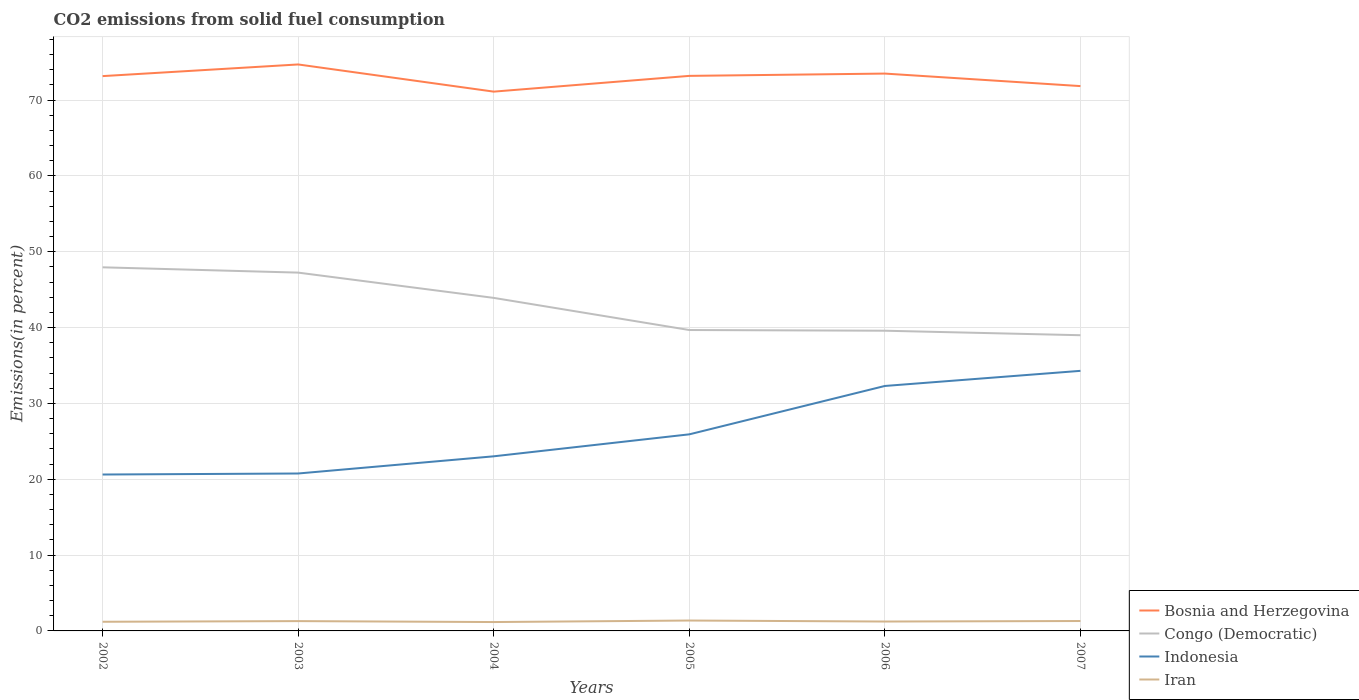Across all years, what is the maximum total CO2 emitted in Indonesia?
Offer a very short reply. 20.62. What is the total total CO2 emitted in Indonesia in the graph?
Offer a terse response. -2.9. What is the difference between the highest and the second highest total CO2 emitted in Bosnia and Herzegovina?
Offer a very short reply. 3.58. How many years are there in the graph?
Your answer should be very brief. 6. What is the difference between two consecutive major ticks on the Y-axis?
Ensure brevity in your answer.  10. Are the values on the major ticks of Y-axis written in scientific E-notation?
Provide a short and direct response. No. Does the graph contain any zero values?
Offer a very short reply. No. What is the title of the graph?
Give a very brief answer. CO2 emissions from solid fuel consumption. What is the label or title of the Y-axis?
Provide a succinct answer. Emissions(in percent). What is the Emissions(in percent) in Bosnia and Herzegovina in 2002?
Keep it short and to the point. 73.15. What is the Emissions(in percent) in Congo (Democratic) in 2002?
Keep it short and to the point. 47.94. What is the Emissions(in percent) in Indonesia in 2002?
Your response must be concise. 20.62. What is the Emissions(in percent) in Iran in 2002?
Make the answer very short. 1.21. What is the Emissions(in percent) in Bosnia and Herzegovina in 2003?
Offer a very short reply. 74.69. What is the Emissions(in percent) of Congo (Democratic) in 2003?
Ensure brevity in your answer.  47.24. What is the Emissions(in percent) of Indonesia in 2003?
Provide a short and direct response. 20.76. What is the Emissions(in percent) of Iran in 2003?
Provide a succinct answer. 1.29. What is the Emissions(in percent) in Bosnia and Herzegovina in 2004?
Ensure brevity in your answer.  71.11. What is the Emissions(in percent) of Congo (Democratic) in 2004?
Give a very brief answer. 43.91. What is the Emissions(in percent) of Indonesia in 2004?
Your answer should be very brief. 23.02. What is the Emissions(in percent) in Iran in 2004?
Your answer should be compact. 1.17. What is the Emissions(in percent) in Bosnia and Herzegovina in 2005?
Your answer should be very brief. 73.18. What is the Emissions(in percent) of Congo (Democratic) in 2005?
Your answer should be compact. 39.68. What is the Emissions(in percent) in Indonesia in 2005?
Your answer should be compact. 25.92. What is the Emissions(in percent) of Iran in 2005?
Your answer should be very brief. 1.37. What is the Emissions(in percent) of Bosnia and Herzegovina in 2006?
Ensure brevity in your answer.  73.49. What is the Emissions(in percent) of Congo (Democratic) in 2006?
Offer a terse response. 39.58. What is the Emissions(in percent) in Indonesia in 2006?
Your answer should be compact. 32.3. What is the Emissions(in percent) in Iran in 2006?
Your response must be concise. 1.24. What is the Emissions(in percent) in Bosnia and Herzegovina in 2007?
Provide a short and direct response. 71.84. What is the Emissions(in percent) in Congo (Democratic) in 2007?
Provide a short and direct response. 38.99. What is the Emissions(in percent) of Indonesia in 2007?
Make the answer very short. 34.29. What is the Emissions(in percent) of Iran in 2007?
Ensure brevity in your answer.  1.31. Across all years, what is the maximum Emissions(in percent) of Bosnia and Herzegovina?
Offer a terse response. 74.69. Across all years, what is the maximum Emissions(in percent) of Congo (Democratic)?
Your answer should be very brief. 47.94. Across all years, what is the maximum Emissions(in percent) of Indonesia?
Offer a terse response. 34.29. Across all years, what is the maximum Emissions(in percent) in Iran?
Give a very brief answer. 1.37. Across all years, what is the minimum Emissions(in percent) of Bosnia and Herzegovina?
Your answer should be very brief. 71.11. Across all years, what is the minimum Emissions(in percent) of Congo (Democratic)?
Make the answer very short. 38.99. Across all years, what is the minimum Emissions(in percent) of Indonesia?
Give a very brief answer. 20.62. Across all years, what is the minimum Emissions(in percent) of Iran?
Provide a succinct answer. 1.17. What is the total Emissions(in percent) in Bosnia and Herzegovina in the graph?
Your answer should be very brief. 437.46. What is the total Emissions(in percent) of Congo (Democratic) in the graph?
Keep it short and to the point. 257.35. What is the total Emissions(in percent) of Indonesia in the graph?
Your answer should be very brief. 156.91. What is the total Emissions(in percent) of Iran in the graph?
Your response must be concise. 7.59. What is the difference between the Emissions(in percent) in Bosnia and Herzegovina in 2002 and that in 2003?
Ensure brevity in your answer.  -1.54. What is the difference between the Emissions(in percent) of Congo (Democratic) in 2002 and that in 2003?
Offer a terse response. 0.7. What is the difference between the Emissions(in percent) in Indonesia in 2002 and that in 2003?
Your answer should be very brief. -0.13. What is the difference between the Emissions(in percent) of Iran in 2002 and that in 2003?
Offer a very short reply. -0.09. What is the difference between the Emissions(in percent) of Bosnia and Herzegovina in 2002 and that in 2004?
Offer a very short reply. 2.05. What is the difference between the Emissions(in percent) in Congo (Democratic) in 2002 and that in 2004?
Offer a very short reply. 4.03. What is the difference between the Emissions(in percent) of Indonesia in 2002 and that in 2004?
Provide a short and direct response. -2.4. What is the difference between the Emissions(in percent) in Iran in 2002 and that in 2004?
Your answer should be compact. 0.04. What is the difference between the Emissions(in percent) in Bosnia and Herzegovina in 2002 and that in 2005?
Keep it short and to the point. -0.03. What is the difference between the Emissions(in percent) of Congo (Democratic) in 2002 and that in 2005?
Your response must be concise. 8.27. What is the difference between the Emissions(in percent) of Indonesia in 2002 and that in 2005?
Make the answer very short. -5.3. What is the difference between the Emissions(in percent) of Iran in 2002 and that in 2005?
Offer a terse response. -0.16. What is the difference between the Emissions(in percent) of Bosnia and Herzegovina in 2002 and that in 2006?
Ensure brevity in your answer.  -0.33. What is the difference between the Emissions(in percent) of Congo (Democratic) in 2002 and that in 2006?
Ensure brevity in your answer.  8.36. What is the difference between the Emissions(in percent) in Indonesia in 2002 and that in 2006?
Your answer should be compact. -11.68. What is the difference between the Emissions(in percent) in Iran in 2002 and that in 2006?
Keep it short and to the point. -0.03. What is the difference between the Emissions(in percent) of Bosnia and Herzegovina in 2002 and that in 2007?
Your answer should be compact. 1.32. What is the difference between the Emissions(in percent) in Congo (Democratic) in 2002 and that in 2007?
Your answer should be very brief. 8.95. What is the difference between the Emissions(in percent) in Indonesia in 2002 and that in 2007?
Keep it short and to the point. -13.67. What is the difference between the Emissions(in percent) of Iran in 2002 and that in 2007?
Offer a very short reply. -0.1. What is the difference between the Emissions(in percent) in Bosnia and Herzegovina in 2003 and that in 2004?
Give a very brief answer. 3.58. What is the difference between the Emissions(in percent) in Congo (Democratic) in 2003 and that in 2004?
Offer a very short reply. 3.33. What is the difference between the Emissions(in percent) of Indonesia in 2003 and that in 2004?
Offer a very short reply. -2.27. What is the difference between the Emissions(in percent) in Iran in 2003 and that in 2004?
Provide a short and direct response. 0.12. What is the difference between the Emissions(in percent) in Bosnia and Herzegovina in 2003 and that in 2005?
Provide a succinct answer. 1.51. What is the difference between the Emissions(in percent) in Congo (Democratic) in 2003 and that in 2005?
Provide a short and direct response. 7.57. What is the difference between the Emissions(in percent) in Indonesia in 2003 and that in 2005?
Keep it short and to the point. -5.16. What is the difference between the Emissions(in percent) in Iran in 2003 and that in 2005?
Keep it short and to the point. -0.08. What is the difference between the Emissions(in percent) of Bosnia and Herzegovina in 2003 and that in 2006?
Ensure brevity in your answer.  1.2. What is the difference between the Emissions(in percent) in Congo (Democratic) in 2003 and that in 2006?
Give a very brief answer. 7.66. What is the difference between the Emissions(in percent) of Indonesia in 2003 and that in 2006?
Offer a terse response. -11.54. What is the difference between the Emissions(in percent) of Iran in 2003 and that in 2006?
Offer a very short reply. 0.05. What is the difference between the Emissions(in percent) of Bosnia and Herzegovina in 2003 and that in 2007?
Your answer should be very brief. 2.85. What is the difference between the Emissions(in percent) in Congo (Democratic) in 2003 and that in 2007?
Ensure brevity in your answer.  8.25. What is the difference between the Emissions(in percent) of Indonesia in 2003 and that in 2007?
Provide a succinct answer. -13.53. What is the difference between the Emissions(in percent) of Iran in 2003 and that in 2007?
Your response must be concise. -0.01. What is the difference between the Emissions(in percent) in Bosnia and Herzegovina in 2004 and that in 2005?
Provide a short and direct response. -2.08. What is the difference between the Emissions(in percent) of Congo (Democratic) in 2004 and that in 2005?
Your answer should be very brief. 4.24. What is the difference between the Emissions(in percent) in Indonesia in 2004 and that in 2005?
Make the answer very short. -2.9. What is the difference between the Emissions(in percent) in Iran in 2004 and that in 2005?
Your answer should be very brief. -0.2. What is the difference between the Emissions(in percent) in Bosnia and Herzegovina in 2004 and that in 2006?
Keep it short and to the point. -2.38. What is the difference between the Emissions(in percent) of Congo (Democratic) in 2004 and that in 2006?
Offer a terse response. 4.33. What is the difference between the Emissions(in percent) of Indonesia in 2004 and that in 2006?
Provide a succinct answer. -9.28. What is the difference between the Emissions(in percent) of Iran in 2004 and that in 2006?
Offer a very short reply. -0.07. What is the difference between the Emissions(in percent) of Bosnia and Herzegovina in 2004 and that in 2007?
Provide a short and direct response. -0.73. What is the difference between the Emissions(in percent) of Congo (Democratic) in 2004 and that in 2007?
Keep it short and to the point. 4.92. What is the difference between the Emissions(in percent) in Indonesia in 2004 and that in 2007?
Your response must be concise. -11.27. What is the difference between the Emissions(in percent) of Iran in 2004 and that in 2007?
Your response must be concise. -0.14. What is the difference between the Emissions(in percent) in Bosnia and Herzegovina in 2005 and that in 2006?
Offer a very short reply. -0.3. What is the difference between the Emissions(in percent) in Congo (Democratic) in 2005 and that in 2006?
Your answer should be very brief. 0.09. What is the difference between the Emissions(in percent) of Indonesia in 2005 and that in 2006?
Your response must be concise. -6.38. What is the difference between the Emissions(in percent) of Iran in 2005 and that in 2006?
Your answer should be compact. 0.13. What is the difference between the Emissions(in percent) in Bosnia and Herzegovina in 2005 and that in 2007?
Offer a terse response. 1.35. What is the difference between the Emissions(in percent) of Congo (Democratic) in 2005 and that in 2007?
Make the answer very short. 0.69. What is the difference between the Emissions(in percent) of Indonesia in 2005 and that in 2007?
Ensure brevity in your answer.  -8.37. What is the difference between the Emissions(in percent) in Iran in 2005 and that in 2007?
Ensure brevity in your answer.  0.06. What is the difference between the Emissions(in percent) in Bosnia and Herzegovina in 2006 and that in 2007?
Ensure brevity in your answer.  1.65. What is the difference between the Emissions(in percent) in Congo (Democratic) in 2006 and that in 2007?
Offer a terse response. 0.59. What is the difference between the Emissions(in percent) of Indonesia in 2006 and that in 2007?
Make the answer very short. -1.99. What is the difference between the Emissions(in percent) in Iran in 2006 and that in 2007?
Provide a short and direct response. -0.07. What is the difference between the Emissions(in percent) in Bosnia and Herzegovina in 2002 and the Emissions(in percent) in Congo (Democratic) in 2003?
Offer a very short reply. 25.91. What is the difference between the Emissions(in percent) of Bosnia and Herzegovina in 2002 and the Emissions(in percent) of Indonesia in 2003?
Offer a very short reply. 52.4. What is the difference between the Emissions(in percent) of Bosnia and Herzegovina in 2002 and the Emissions(in percent) of Iran in 2003?
Offer a terse response. 71.86. What is the difference between the Emissions(in percent) of Congo (Democratic) in 2002 and the Emissions(in percent) of Indonesia in 2003?
Keep it short and to the point. 27.19. What is the difference between the Emissions(in percent) in Congo (Democratic) in 2002 and the Emissions(in percent) in Iran in 2003?
Offer a terse response. 46.65. What is the difference between the Emissions(in percent) of Indonesia in 2002 and the Emissions(in percent) of Iran in 2003?
Provide a short and direct response. 19.33. What is the difference between the Emissions(in percent) in Bosnia and Herzegovina in 2002 and the Emissions(in percent) in Congo (Democratic) in 2004?
Provide a short and direct response. 29.24. What is the difference between the Emissions(in percent) in Bosnia and Herzegovina in 2002 and the Emissions(in percent) in Indonesia in 2004?
Provide a short and direct response. 50.13. What is the difference between the Emissions(in percent) in Bosnia and Herzegovina in 2002 and the Emissions(in percent) in Iran in 2004?
Give a very brief answer. 71.98. What is the difference between the Emissions(in percent) of Congo (Democratic) in 2002 and the Emissions(in percent) of Indonesia in 2004?
Your answer should be very brief. 24.92. What is the difference between the Emissions(in percent) of Congo (Democratic) in 2002 and the Emissions(in percent) of Iran in 2004?
Your answer should be very brief. 46.77. What is the difference between the Emissions(in percent) of Indonesia in 2002 and the Emissions(in percent) of Iran in 2004?
Your answer should be compact. 19.45. What is the difference between the Emissions(in percent) of Bosnia and Herzegovina in 2002 and the Emissions(in percent) of Congo (Democratic) in 2005?
Keep it short and to the point. 33.48. What is the difference between the Emissions(in percent) of Bosnia and Herzegovina in 2002 and the Emissions(in percent) of Indonesia in 2005?
Keep it short and to the point. 47.23. What is the difference between the Emissions(in percent) of Bosnia and Herzegovina in 2002 and the Emissions(in percent) of Iran in 2005?
Your answer should be very brief. 71.78. What is the difference between the Emissions(in percent) of Congo (Democratic) in 2002 and the Emissions(in percent) of Indonesia in 2005?
Your answer should be very brief. 22.02. What is the difference between the Emissions(in percent) of Congo (Democratic) in 2002 and the Emissions(in percent) of Iran in 2005?
Your answer should be very brief. 46.57. What is the difference between the Emissions(in percent) in Indonesia in 2002 and the Emissions(in percent) in Iran in 2005?
Your response must be concise. 19.25. What is the difference between the Emissions(in percent) of Bosnia and Herzegovina in 2002 and the Emissions(in percent) of Congo (Democratic) in 2006?
Provide a succinct answer. 33.57. What is the difference between the Emissions(in percent) in Bosnia and Herzegovina in 2002 and the Emissions(in percent) in Indonesia in 2006?
Offer a very short reply. 40.86. What is the difference between the Emissions(in percent) in Bosnia and Herzegovina in 2002 and the Emissions(in percent) in Iran in 2006?
Make the answer very short. 71.92. What is the difference between the Emissions(in percent) in Congo (Democratic) in 2002 and the Emissions(in percent) in Indonesia in 2006?
Give a very brief answer. 15.64. What is the difference between the Emissions(in percent) in Congo (Democratic) in 2002 and the Emissions(in percent) in Iran in 2006?
Keep it short and to the point. 46.7. What is the difference between the Emissions(in percent) in Indonesia in 2002 and the Emissions(in percent) in Iran in 2006?
Make the answer very short. 19.38. What is the difference between the Emissions(in percent) in Bosnia and Herzegovina in 2002 and the Emissions(in percent) in Congo (Democratic) in 2007?
Offer a very short reply. 34.16. What is the difference between the Emissions(in percent) in Bosnia and Herzegovina in 2002 and the Emissions(in percent) in Indonesia in 2007?
Give a very brief answer. 38.86. What is the difference between the Emissions(in percent) of Bosnia and Herzegovina in 2002 and the Emissions(in percent) of Iran in 2007?
Your response must be concise. 71.85. What is the difference between the Emissions(in percent) of Congo (Democratic) in 2002 and the Emissions(in percent) of Indonesia in 2007?
Provide a succinct answer. 13.65. What is the difference between the Emissions(in percent) of Congo (Democratic) in 2002 and the Emissions(in percent) of Iran in 2007?
Keep it short and to the point. 46.64. What is the difference between the Emissions(in percent) of Indonesia in 2002 and the Emissions(in percent) of Iran in 2007?
Make the answer very short. 19.32. What is the difference between the Emissions(in percent) in Bosnia and Herzegovina in 2003 and the Emissions(in percent) in Congo (Democratic) in 2004?
Make the answer very short. 30.78. What is the difference between the Emissions(in percent) of Bosnia and Herzegovina in 2003 and the Emissions(in percent) of Indonesia in 2004?
Your response must be concise. 51.67. What is the difference between the Emissions(in percent) of Bosnia and Herzegovina in 2003 and the Emissions(in percent) of Iran in 2004?
Keep it short and to the point. 73.52. What is the difference between the Emissions(in percent) in Congo (Democratic) in 2003 and the Emissions(in percent) in Indonesia in 2004?
Your response must be concise. 24.22. What is the difference between the Emissions(in percent) of Congo (Democratic) in 2003 and the Emissions(in percent) of Iran in 2004?
Your answer should be very brief. 46.07. What is the difference between the Emissions(in percent) of Indonesia in 2003 and the Emissions(in percent) of Iran in 2004?
Offer a terse response. 19.59. What is the difference between the Emissions(in percent) of Bosnia and Herzegovina in 2003 and the Emissions(in percent) of Congo (Democratic) in 2005?
Offer a terse response. 35.01. What is the difference between the Emissions(in percent) of Bosnia and Herzegovina in 2003 and the Emissions(in percent) of Indonesia in 2005?
Offer a terse response. 48.77. What is the difference between the Emissions(in percent) in Bosnia and Herzegovina in 2003 and the Emissions(in percent) in Iran in 2005?
Your response must be concise. 73.32. What is the difference between the Emissions(in percent) in Congo (Democratic) in 2003 and the Emissions(in percent) in Indonesia in 2005?
Ensure brevity in your answer.  21.32. What is the difference between the Emissions(in percent) of Congo (Democratic) in 2003 and the Emissions(in percent) of Iran in 2005?
Provide a succinct answer. 45.87. What is the difference between the Emissions(in percent) of Indonesia in 2003 and the Emissions(in percent) of Iran in 2005?
Keep it short and to the point. 19.39. What is the difference between the Emissions(in percent) in Bosnia and Herzegovina in 2003 and the Emissions(in percent) in Congo (Democratic) in 2006?
Provide a short and direct response. 35.11. What is the difference between the Emissions(in percent) of Bosnia and Herzegovina in 2003 and the Emissions(in percent) of Indonesia in 2006?
Keep it short and to the point. 42.39. What is the difference between the Emissions(in percent) of Bosnia and Herzegovina in 2003 and the Emissions(in percent) of Iran in 2006?
Provide a succinct answer. 73.45. What is the difference between the Emissions(in percent) of Congo (Democratic) in 2003 and the Emissions(in percent) of Indonesia in 2006?
Offer a terse response. 14.95. What is the difference between the Emissions(in percent) of Congo (Democratic) in 2003 and the Emissions(in percent) of Iran in 2006?
Offer a very short reply. 46.01. What is the difference between the Emissions(in percent) in Indonesia in 2003 and the Emissions(in percent) in Iran in 2006?
Offer a very short reply. 19.52. What is the difference between the Emissions(in percent) in Bosnia and Herzegovina in 2003 and the Emissions(in percent) in Congo (Democratic) in 2007?
Your response must be concise. 35.7. What is the difference between the Emissions(in percent) of Bosnia and Herzegovina in 2003 and the Emissions(in percent) of Indonesia in 2007?
Give a very brief answer. 40.4. What is the difference between the Emissions(in percent) in Bosnia and Herzegovina in 2003 and the Emissions(in percent) in Iran in 2007?
Your answer should be compact. 73.38. What is the difference between the Emissions(in percent) in Congo (Democratic) in 2003 and the Emissions(in percent) in Indonesia in 2007?
Provide a short and direct response. 12.95. What is the difference between the Emissions(in percent) of Congo (Democratic) in 2003 and the Emissions(in percent) of Iran in 2007?
Ensure brevity in your answer.  45.94. What is the difference between the Emissions(in percent) in Indonesia in 2003 and the Emissions(in percent) in Iran in 2007?
Offer a terse response. 19.45. What is the difference between the Emissions(in percent) in Bosnia and Herzegovina in 2004 and the Emissions(in percent) in Congo (Democratic) in 2005?
Your answer should be compact. 31.43. What is the difference between the Emissions(in percent) of Bosnia and Herzegovina in 2004 and the Emissions(in percent) of Indonesia in 2005?
Your answer should be very brief. 45.19. What is the difference between the Emissions(in percent) of Bosnia and Herzegovina in 2004 and the Emissions(in percent) of Iran in 2005?
Your response must be concise. 69.74. What is the difference between the Emissions(in percent) in Congo (Democratic) in 2004 and the Emissions(in percent) in Indonesia in 2005?
Keep it short and to the point. 17.99. What is the difference between the Emissions(in percent) of Congo (Democratic) in 2004 and the Emissions(in percent) of Iran in 2005?
Give a very brief answer. 42.54. What is the difference between the Emissions(in percent) of Indonesia in 2004 and the Emissions(in percent) of Iran in 2005?
Your answer should be compact. 21.65. What is the difference between the Emissions(in percent) of Bosnia and Herzegovina in 2004 and the Emissions(in percent) of Congo (Democratic) in 2006?
Ensure brevity in your answer.  31.52. What is the difference between the Emissions(in percent) of Bosnia and Herzegovina in 2004 and the Emissions(in percent) of Indonesia in 2006?
Make the answer very short. 38.81. What is the difference between the Emissions(in percent) of Bosnia and Herzegovina in 2004 and the Emissions(in percent) of Iran in 2006?
Your answer should be very brief. 69.87. What is the difference between the Emissions(in percent) of Congo (Democratic) in 2004 and the Emissions(in percent) of Indonesia in 2006?
Offer a very short reply. 11.61. What is the difference between the Emissions(in percent) of Congo (Democratic) in 2004 and the Emissions(in percent) of Iran in 2006?
Your answer should be compact. 42.67. What is the difference between the Emissions(in percent) in Indonesia in 2004 and the Emissions(in percent) in Iran in 2006?
Your answer should be very brief. 21.78. What is the difference between the Emissions(in percent) in Bosnia and Herzegovina in 2004 and the Emissions(in percent) in Congo (Democratic) in 2007?
Keep it short and to the point. 32.12. What is the difference between the Emissions(in percent) in Bosnia and Herzegovina in 2004 and the Emissions(in percent) in Indonesia in 2007?
Your answer should be very brief. 36.81. What is the difference between the Emissions(in percent) of Bosnia and Herzegovina in 2004 and the Emissions(in percent) of Iran in 2007?
Offer a very short reply. 69.8. What is the difference between the Emissions(in percent) in Congo (Democratic) in 2004 and the Emissions(in percent) in Indonesia in 2007?
Give a very brief answer. 9.62. What is the difference between the Emissions(in percent) of Congo (Democratic) in 2004 and the Emissions(in percent) of Iran in 2007?
Give a very brief answer. 42.6. What is the difference between the Emissions(in percent) in Indonesia in 2004 and the Emissions(in percent) in Iran in 2007?
Offer a very short reply. 21.72. What is the difference between the Emissions(in percent) of Bosnia and Herzegovina in 2005 and the Emissions(in percent) of Congo (Democratic) in 2006?
Your response must be concise. 33.6. What is the difference between the Emissions(in percent) of Bosnia and Herzegovina in 2005 and the Emissions(in percent) of Indonesia in 2006?
Provide a short and direct response. 40.89. What is the difference between the Emissions(in percent) in Bosnia and Herzegovina in 2005 and the Emissions(in percent) in Iran in 2006?
Provide a succinct answer. 71.95. What is the difference between the Emissions(in percent) of Congo (Democratic) in 2005 and the Emissions(in percent) of Indonesia in 2006?
Keep it short and to the point. 7.38. What is the difference between the Emissions(in percent) of Congo (Democratic) in 2005 and the Emissions(in percent) of Iran in 2006?
Your answer should be compact. 38.44. What is the difference between the Emissions(in percent) in Indonesia in 2005 and the Emissions(in percent) in Iran in 2006?
Provide a succinct answer. 24.68. What is the difference between the Emissions(in percent) of Bosnia and Herzegovina in 2005 and the Emissions(in percent) of Congo (Democratic) in 2007?
Offer a very short reply. 34.19. What is the difference between the Emissions(in percent) of Bosnia and Herzegovina in 2005 and the Emissions(in percent) of Indonesia in 2007?
Make the answer very short. 38.89. What is the difference between the Emissions(in percent) of Bosnia and Herzegovina in 2005 and the Emissions(in percent) of Iran in 2007?
Make the answer very short. 71.88. What is the difference between the Emissions(in percent) of Congo (Democratic) in 2005 and the Emissions(in percent) of Indonesia in 2007?
Ensure brevity in your answer.  5.38. What is the difference between the Emissions(in percent) in Congo (Democratic) in 2005 and the Emissions(in percent) in Iran in 2007?
Your answer should be very brief. 38.37. What is the difference between the Emissions(in percent) in Indonesia in 2005 and the Emissions(in percent) in Iran in 2007?
Your answer should be compact. 24.61. What is the difference between the Emissions(in percent) of Bosnia and Herzegovina in 2006 and the Emissions(in percent) of Congo (Democratic) in 2007?
Provide a short and direct response. 34.5. What is the difference between the Emissions(in percent) in Bosnia and Herzegovina in 2006 and the Emissions(in percent) in Indonesia in 2007?
Offer a very short reply. 39.19. What is the difference between the Emissions(in percent) of Bosnia and Herzegovina in 2006 and the Emissions(in percent) of Iran in 2007?
Your answer should be compact. 72.18. What is the difference between the Emissions(in percent) in Congo (Democratic) in 2006 and the Emissions(in percent) in Indonesia in 2007?
Provide a short and direct response. 5.29. What is the difference between the Emissions(in percent) in Congo (Democratic) in 2006 and the Emissions(in percent) in Iran in 2007?
Give a very brief answer. 38.28. What is the difference between the Emissions(in percent) of Indonesia in 2006 and the Emissions(in percent) of Iran in 2007?
Ensure brevity in your answer.  30.99. What is the average Emissions(in percent) of Bosnia and Herzegovina per year?
Provide a succinct answer. 72.91. What is the average Emissions(in percent) of Congo (Democratic) per year?
Your response must be concise. 42.89. What is the average Emissions(in percent) in Indonesia per year?
Provide a short and direct response. 26.15. What is the average Emissions(in percent) of Iran per year?
Make the answer very short. 1.26. In the year 2002, what is the difference between the Emissions(in percent) in Bosnia and Herzegovina and Emissions(in percent) in Congo (Democratic)?
Provide a succinct answer. 25.21. In the year 2002, what is the difference between the Emissions(in percent) of Bosnia and Herzegovina and Emissions(in percent) of Indonesia?
Your answer should be compact. 52.53. In the year 2002, what is the difference between the Emissions(in percent) of Bosnia and Herzegovina and Emissions(in percent) of Iran?
Offer a terse response. 71.95. In the year 2002, what is the difference between the Emissions(in percent) of Congo (Democratic) and Emissions(in percent) of Indonesia?
Ensure brevity in your answer.  27.32. In the year 2002, what is the difference between the Emissions(in percent) in Congo (Democratic) and Emissions(in percent) in Iran?
Make the answer very short. 46.74. In the year 2002, what is the difference between the Emissions(in percent) of Indonesia and Emissions(in percent) of Iran?
Ensure brevity in your answer.  19.42. In the year 2003, what is the difference between the Emissions(in percent) in Bosnia and Herzegovina and Emissions(in percent) in Congo (Democratic)?
Give a very brief answer. 27.45. In the year 2003, what is the difference between the Emissions(in percent) of Bosnia and Herzegovina and Emissions(in percent) of Indonesia?
Provide a succinct answer. 53.93. In the year 2003, what is the difference between the Emissions(in percent) of Bosnia and Herzegovina and Emissions(in percent) of Iran?
Provide a succinct answer. 73.4. In the year 2003, what is the difference between the Emissions(in percent) in Congo (Democratic) and Emissions(in percent) in Indonesia?
Give a very brief answer. 26.49. In the year 2003, what is the difference between the Emissions(in percent) of Congo (Democratic) and Emissions(in percent) of Iran?
Provide a succinct answer. 45.95. In the year 2003, what is the difference between the Emissions(in percent) of Indonesia and Emissions(in percent) of Iran?
Your answer should be compact. 19.46. In the year 2004, what is the difference between the Emissions(in percent) of Bosnia and Herzegovina and Emissions(in percent) of Congo (Democratic)?
Make the answer very short. 27.2. In the year 2004, what is the difference between the Emissions(in percent) in Bosnia and Herzegovina and Emissions(in percent) in Indonesia?
Make the answer very short. 48.08. In the year 2004, what is the difference between the Emissions(in percent) of Bosnia and Herzegovina and Emissions(in percent) of Iran?
Ensure brevity in your answer.  69.94. In the year 2004, what is the difference between the Emissions(in percent) of Congo (Democratic) and Emissions(in percent) of Indonesia?
Provide a short and direct response. 20.89. In the year 2004, what is the difference between the Emissions(in percent) in Congo (Democratic) and Emissions(in percent) in Iran?
Offer a very short reply. 42.74. In the year 2004, what is the difference between the Emissions(in percent) of Indonesia and Emissions(in percent) of Iran?
Make the answer very short. 21.85. In the year 2005, what is the difference between the Emissions(in percent) of Bosnia and Herzegovina and Emissions(in percent) of Congo (Democratic)?
Ensure brevity in your answer.  33.51. In the year 2005, what is the difference between the Emissions(in percent) of Bosnia and Herzegovina and Emissions(in percent) of Indonesia?
Your answer should be compact. 47.26. In the year 2005, what is the difference between the Emissions(in percent) in Bosnia and Herzegovina and Emissions(in percent) in Iran?
Your answer should be very brief. 71.81. In the year 2005, what is the difference between the Emissions(in percent) in Congo (Democratic) and Emissions(in percent) in Indonesia?
Provide a succinct answer. 13.76. In the year 2005, what is the difference between the Emissions(in percent) of Congo (Democratic) and Emissions(in percent) of Iran?
Ensure brevity in your answer.  38.31. In the year 2005, what is the difference between the Emissions(in percent) in Indonesia and Emissions(in percent) in Iran?
Ensure brevity in your answer.  24.55. In the year 2006, what is the difference between the Emissions(in percent) of Bosnia and Herzegovina and Emissions(in percent) of Congo (Democratic)?
Ensure brevity in your answer.  33.9. In the year 2006, what is the difference between the Emissions(in percent) of Bosnia and Herzegovina and Emissions(in percent) of Indonesia?
Your response must be concise. 41.19. In the year 2006, what is the difference between the Emissions(in percent) of Bosnia and Herzegovina and Emissions(in percent) of Iran?
Offer a very short reply. 72.25. In the year 2006, what is the difference between the Emissions(in percent) in Congo (Democratic) and Emissions(in percent) in Indonesia?
Provide a succinct answer. 7.28. In the year 2006, what is the difference between the Emissions(in percent) in Congo (Democratic) and Emissions(in percent) in Iran?
Your answer should be compact. 38.34. In the year 2006, what is the difference between the Emissions(in percent) in Indonesia and Emissions(in percent) in Iran?
Your answer should be compact. 31.06. In the year 2007, what is the difference between the Emissions(in percent) of Bosnia and Herzegovina and Emissions(in percent) of Congo (Democratic)?
Give a very brief answer. 32.85. In the year 2007, what is the difference between the Emissions(in percent) of Bosnia and Herzegovina and Emissions(in percent) of Indonesia?
Offer a terse response. 37.54. In the year 2007, what is the difference between the Emissions(in percent) in Bosnia and Herzegovina and Emissions(in percent) in Iran?
Provide a short and direct response. 70.53. In the year 2007, what is the difference between the Emissions(in percent) of Congo (Democratic) and Emissions(in percent) of Indonesia?
Provide a succinct answer. 4.7. In the year 2007, what is the difference between the Emissions(in percent) of Congo (Democratic) and Emissions(in percent) of Iran?
Your answer should be compact. 37.68. In the year 2007, what is the difference between the Emissions(in percent) in Indonesia and Emissions(in percent) in Iran?
Keep it short and to the point. 32.99. What is the ratio of the Emissions(in percent) in Bosnia and Herzegovina in 2002 to that in 2003?
Offer a terse response. 0.98. What is the ratio of the Emissions(in percent) in Congo (Democratic) in 2002 to that in 2003?
Your response must be concise. 1.01. What is the ratio of the Emissions(in percent) in Indonesia in 2002 to that in 2003?
Your answer should be compact. 0.99. What is the ratio of the Emissions(in percent) in Iran in 2002 to that in 2003?
Your answer should be very brief. 0.93. What is the ratio of the Emissions(in percent) in Bosnia and Herzegovina in 2002 to that in 2004?
Keep it short and to the point. 1.03. What is the ratio of the Emissions(in percent) of Congo (Democratic) in 2002 to that in 2004?
Provide a short and direct response. 1.09. What is the ratio of the Emissions(in percent) in Indonesia in 2002 to that in 2004?
Your response must be concise. 0.9. What is the ratio of the Emissions(in percent) in Iran in 2002 to that in 2004?
Your response must be concise. 1.03. What is the ratio of the Emissions(in percent) in Congo (Democratic) in 2002 to that in 2005?
Ensure brevity in your answer.  1.21. What is the ratio of the Emissions(in percent) of Indonesia in 2002 to that in 2005?
Offer a very short reply. 0.8. What is the ratio of the Emissions(in percent) of Iran in 2002 to that in 2005?
Keep it short and to the point. 0.88. What is the ratio of the Emissions(in percent) in Congo (Democratic) in 2002 to that in 2006?
Offer a terse response. 1.21. What is the ratio of the Emissions(in percent) of Indonesia in 2002 to that in 2006?
Keep it short and to the point. 0.64. What is the ratio of the Emissions(in percent) of Iran in 2002 to that in 2006?
Provide a succinct answer. 0.97. What is the ratio of the Emissions(in percent) of Bosnia and Herzegovina in 2002 to that in 2007?
Your response must be concise. 1.02. What is the ratio of the Emissions(in percent) in Congo (Democratic) in 2002 to that in 2007?
Offer a very short reply. 1.23. What is the ratio of the Emissions(in percent) of Indonesia in 2002 to that in 2007?
Provide a succinct answer. 0.6. What is the ratio of the Emissions(in percent) of Iran in 2002 to that in 2007?
Offer a terse response. 0.92. What is the ratio of the Emissions(in percent) of Bosnia and Herzegovina in 2003 to that in 2004?
Your answer should be compact. 1.05. What is the ratio of the Emissions(in percent) of Congo (Democratic) in 2003 to that in 2004?
Offer a very short reply. 1.08. What is the ratio of the Emissions(in percent) of Indonesia in 2003 to that in 2004?
Provide a short and direct response. 0.9. What is the ratio of the Emissions(in percent) of Iran in 2003 to that in 2004?
Ensure brevity in your answer.  1.1. What is the ratio of the Emissions(in percent) in Bosnia and Herzegovina in 2003 to that in 2005?
Provide a short and direct response. 1.02. What is the ratio of the Emissions(in percent) in Congo (Democratic) in 2003 to that in 2005?
Offer a very short reply. 1.19. What is the ratio of the Emissions(in percent) in Indonesia in 2003 to that in 2005?
Offer a terse response. 0.8. What is the ratio of the Emissions(in percent) in Iran in 2003 to that in 2005?
Make the answer very short. 0.94. What is the ratio of the Emissions(in percent) of Bosnia and Herzegovina in 2003 to that in 2006?
Provide a succinct answer. 1.02. What is the ratio of the Emissions(in percent) in Congo (Democratic) in 2003 to that in 2006?
Provide a short and direct response. 1.19. What is the ratio of the Emissions(in percent) of Indonesia in 2003 to that in 2006?
Your answer should be very brief. 0.64. What is the ratio of the Emissions(in percent) in Iran in 2003 to that in 2006?
Offer a terse response. 1.04. What is the ratio of the Emissions(in percent) in Bosnia and Herzegovina in 2003 to that in 2007?
Make the answer very short. 1.04. What is the ratio of the Emissions(in percent) in Congo (Democratic) in 2003 to that in 2007?
Offer a terse response. 1.21. What is the ratio of the Emissions(in percent) of Indonesia in 2003 to that in 2007?
Your answer should be compact. 0.61. What is the ratio of the Emissions(in percent) in Iran in 2003 to that in 2007?
Your response must be concise. 0.99. What is the ratio of the Emissions(in percent) of Bosnia and Herzegovina in 2004 to that in 2005?
Offer a very short reply. 0.97. What is the ratio of the Emissions(in percent) of Congo (Democratic) in 2004 to that in 2005?
Keep it short and to the point. 1.11. What is the ratio of the Emissions(in percent) of Indonesia in 2004 to that in 2005?
Offer a very short reply. 0.89. What is the ratio of the Emissions(in percent) in Iran in 2004 to that in 2005?
Keep it short and to the point. 0.85. What is the ratio of the Emissions(in percent) in Bosnia and Herzegovina in 2004 to that in 2006?
Ensure brevity in your answer.  0.97. What is the ratio of the Emissions(in percent) in Congo (Democratic) in 2004 to that in 2006?
Offer a terse response. 1.11. What is the ratio of the Emissions(in percent) of Indonesia in 2004 to that in 2006?
Provide a succinct answer. 0.71. What is the ratio of the Emissions(in percent) of Iran in 2004 to that in 2006?
Provide a succinct answer. 0.94. What is the ratio of the Emissions(in percent) of Bosnia and Herzegovina in 2004 to that in 2007?
Offer a very short reply. 0.99. What is the ratio of the Emissions(in percent) in Congo (Democratic) in 2004 to that in 2007?
Give a very brief answer. 1.13. What is the ratio of the Emissions(in percent) in Indonesia in 2004 to that in 2007?
Your response must be concise. 0.67. What is the ratio of the Emissions(in percent) of Iran in 2004 to that in 2007?
Provide a short and direct response. 0.9. What is the ratio of the Emissions(in percent) of Congo (Democratic) in 2005 to that in 2006?
Offer a terse response. 1. What is the ratio of the Emissions(in percent) of Indonesia in 2005 to that in 2006?
Provide a short and direct response. 0.8. What is the ratio of the Emissions(in percent) in Iran in 2005 to that in 2006?
Provide a short and direct response. 1.11. What is the ratio of the Emissions(in percent) of Bosnia and Herzegovina in 2005 to that in 2007?
Provide a short and direct response. 1.02. What is the ratio of the Emissions(in percent) of Congo (Democratic) in 2005 to that in 2007?
Keep it short and to the point. 1.02. What is the ratio of the Emissions(in percent) in Indonesia in 2005 to that in 2007?
Offer a very short reply. 0.76. What is the ratio of the Emissions(in percent) in Iran in 2005 to that in 2007?
Your response must be concise. 1.05. What is the ratio of the Emissions(in percent) of Congo (Democratic) in 2006 to that in 2007?
Your response must be concise. 1.02. What is the ratio of the Emissions(in percent) of Indonesia in 2006 to that in 2007?
Your answer should be very brief. 0.94. What is the ratio of the Emissions(in percent) in Iran in 2006 to that in 2007?
Ensure brevity in your answer.  0.95. What is the difference between the highest and the second highest Emissions(in percent) in Bosnia and Herzegovina?
Keep it short and to the point. 1.2. What is the difference between the highest and the second highest Emissions(in percent) in Congo (Democratic)?
Provide a succinct answer. 0.7. What is the difference between the highest and the second highest Emissions(in percent) in Indonesia?
Your response must be concise. 1.99. What is the difference between the highest and the second highest Emissions(in percent) of Iran?
Offer a very short reply. 0.06. What is the difference between the highest and the lowest Emissions(in percent) of Bosnia and Herzegovina?
Your answer should be very brief. 3.58. What is the difference between the highest and the lowest Emissions(in percent) in Congo (Democratic)?
Your answer should be very brief. 8.95. What is the difference between the highest and the lowest Emissions(in percent) of Indonesia?
Provide a short and direct response. 13.67. What is the difference between the highest and the lowest Emissions(in percent) of Iran?
Your response must be concise. 0.2. 